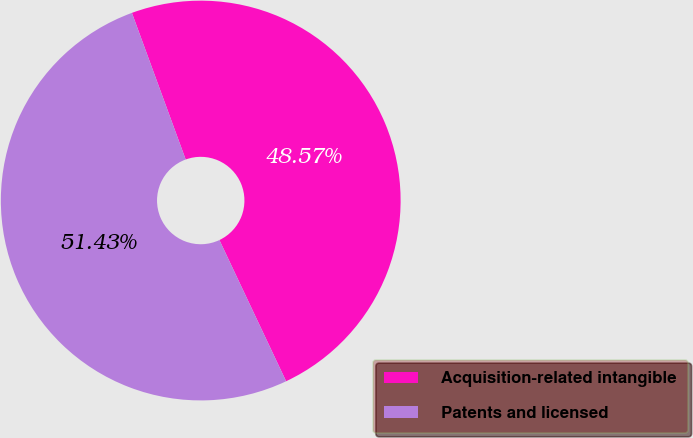<chart> <loc_0><loc_0><loc_500><loc_500><pie_chart><fcel>Acquisition-related intangible<fcel>Patents and licensed<nl><fcel>48.57%<fcel>51.43%<nl></chart> 